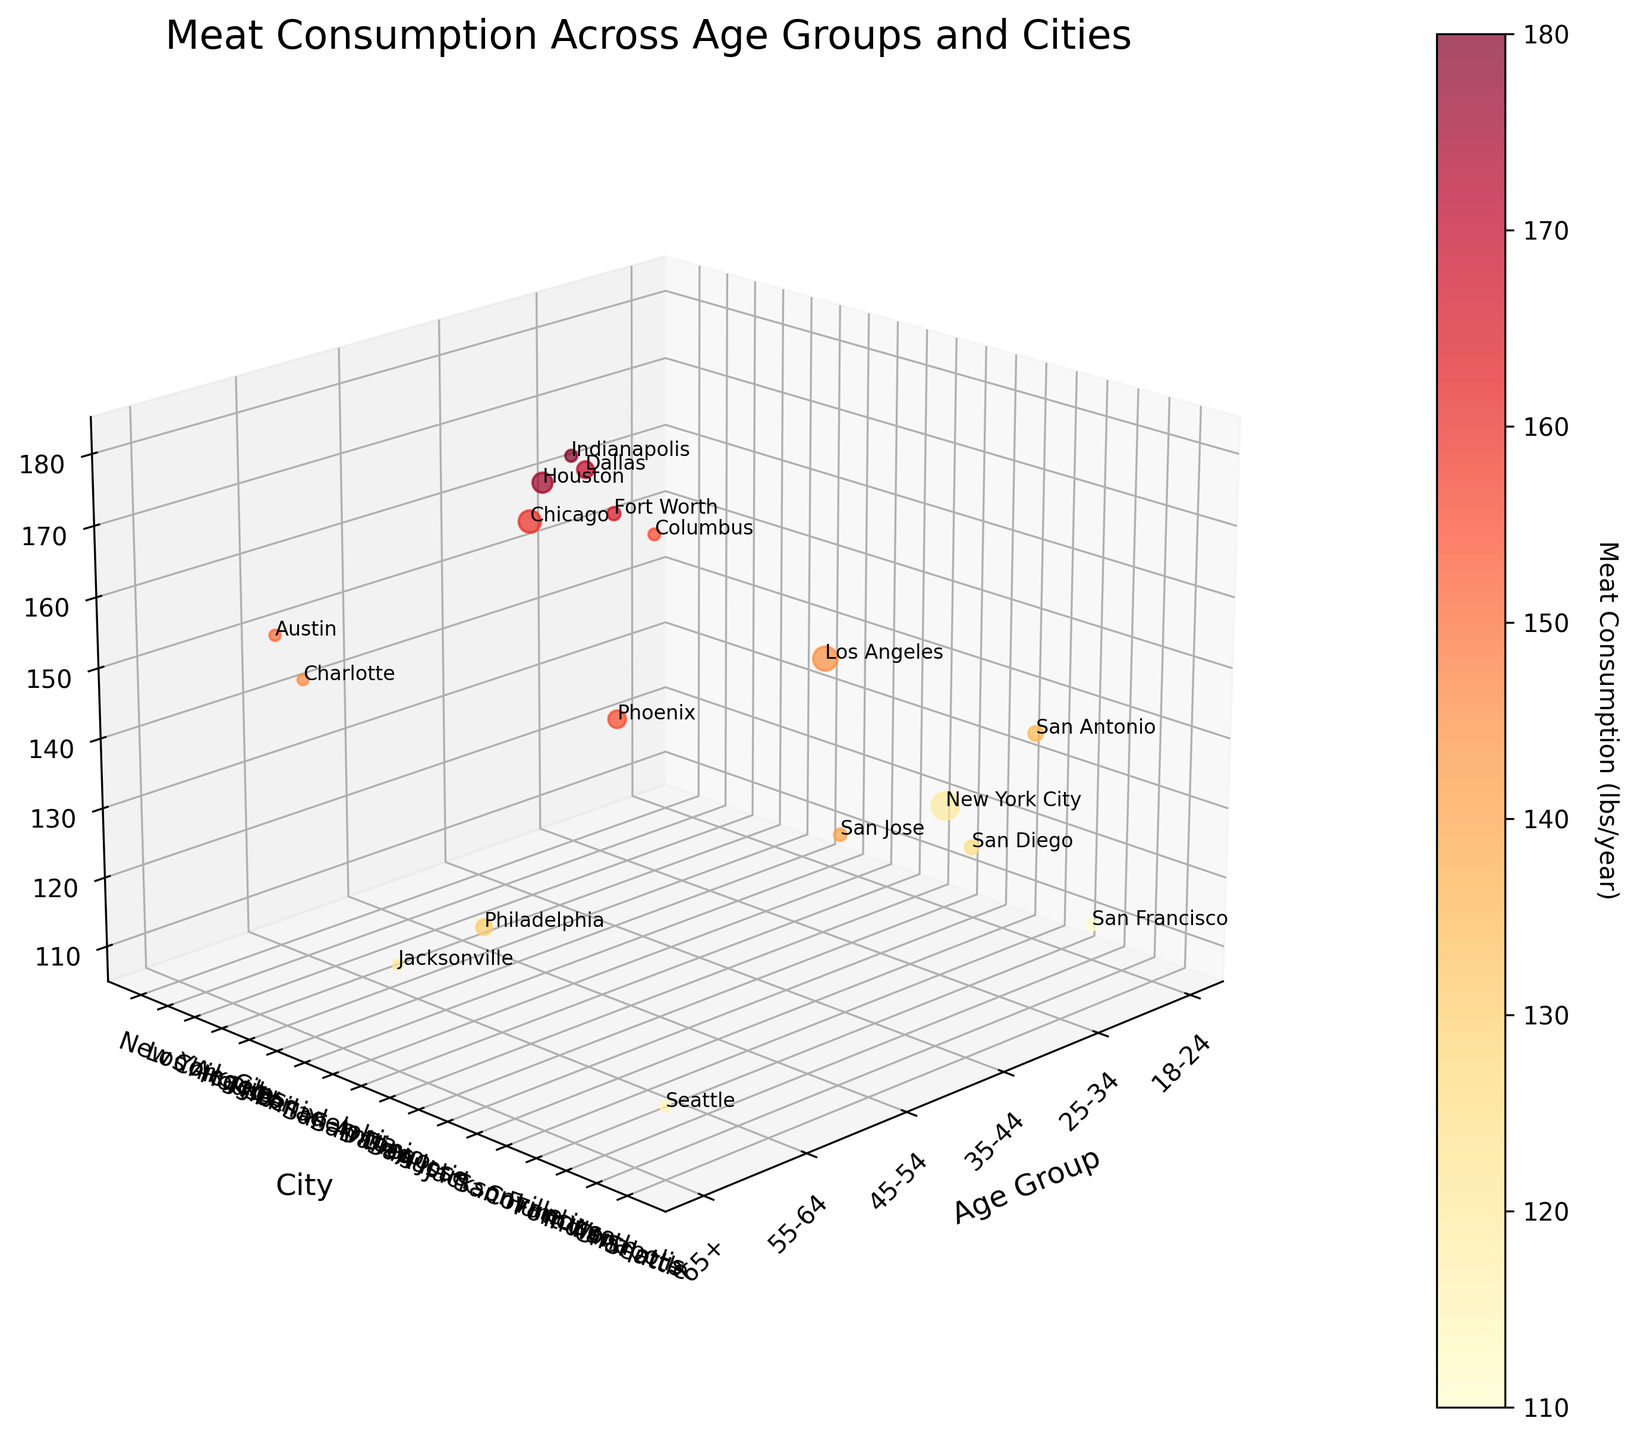How many age groups are represented in the plot? The x-axis represents the age groups, and there are labels for six distinct groups.
Answer: 6 Which city has the largest bubble size? The bubble size is proportional to the population. The city with the largest bubble is New York City, given its highest population value of 1,200,000.
Answer: New York City What is the color range used for the meat consumption values? The color of the bubbles ranges from yellow to red based on meat consumption values, as indicated by the color bar.
Answer: Yellow to red What's the meat consumption for the 45-54 age group in Indianapolis? Locate the 45-54 age group on the x-axis, find Indianapolis on the y-axis, and check the corresponding z-axis value or the bubble close to it.
Answer: 180 lbs/year Compare the meat consumption between the 35-44 age group in Chicago and Dallas. Which one is higher? For the 35-44 age group, look at the z-values for Chicago and Dallas. Chicago has a meat consumption of 160 lbs/year, while Dallas has 170 lbs/year.
Answer: Dallas What's the average meat consumption for the 55-64 age group across all presented cities? Sum up the meat consumption for each city in the 55-64 age group (Phoenix: 155, Austin: 150, Charlotte: 145) and divide by the number of cities (3). 155 + 150 + 145 = 450, 450/3 = 150 lbs/year.
Answer: 150 lbs/year Identify the city with the lowest meat consumption for the 18-24 age group. Check the z-values for the 18-24 age group across all cities listed. San Francisco has the lowest value of 110 lbs/year.
Answer: San Francisco How does the meat consumption of the 25-34 age group in Los Angeles compare with that in San Diego? The z-value for Los Angeles is 145 lbs/year, and for San Diego, it is 125 lbs/year. Los Angeles has higher meat consumption.
Answer: Los Angeles What is the total population represented in the 65+ age group across the cities? Sum the population of all cities representing the 65+ age group (Philadelphia: 400,000, Jacksonville: 150,000, Seattle: 170,000). 400,000 + 150,000 + 170,000 = 720,000.
Answer: 720,000 Which age group in Houston consumes the most meat, and what is the amount? Find Houston on the y-axis and check the z-values for all age groups; the highest is the 45-54 age group with 175 lbs/year.
Answer: 45-54, 175 lbs/year 